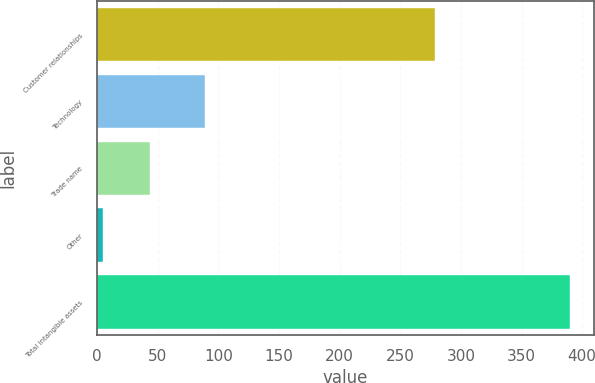<chart> <loc_0><loc_0><loc_500><loc_500><bar_chart><fcel>Customer relationships<fcel>Technology<fcel>Trade name<fcel>Other<fcel>Total intangible assets<nl><fcel>279<fcel>89<fcel>43.5<fcel>5<fcel>390<nl></chart> 